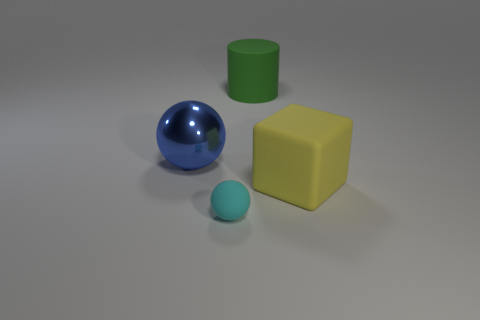Add 2 large blue cubes. How many objects exist? 6 Subtract all cylinders. How many objects are left? 3 Subtract 0 red cylinders. How many objects are left? 4 Subtract all small balls. Subtract all tiny rubber objects. How many objects are left? 2 Add 3 rubber cubes. How many rubber cubes are left? 4 Add 2 big yellow objects. How many big yellow objects exist? 3 